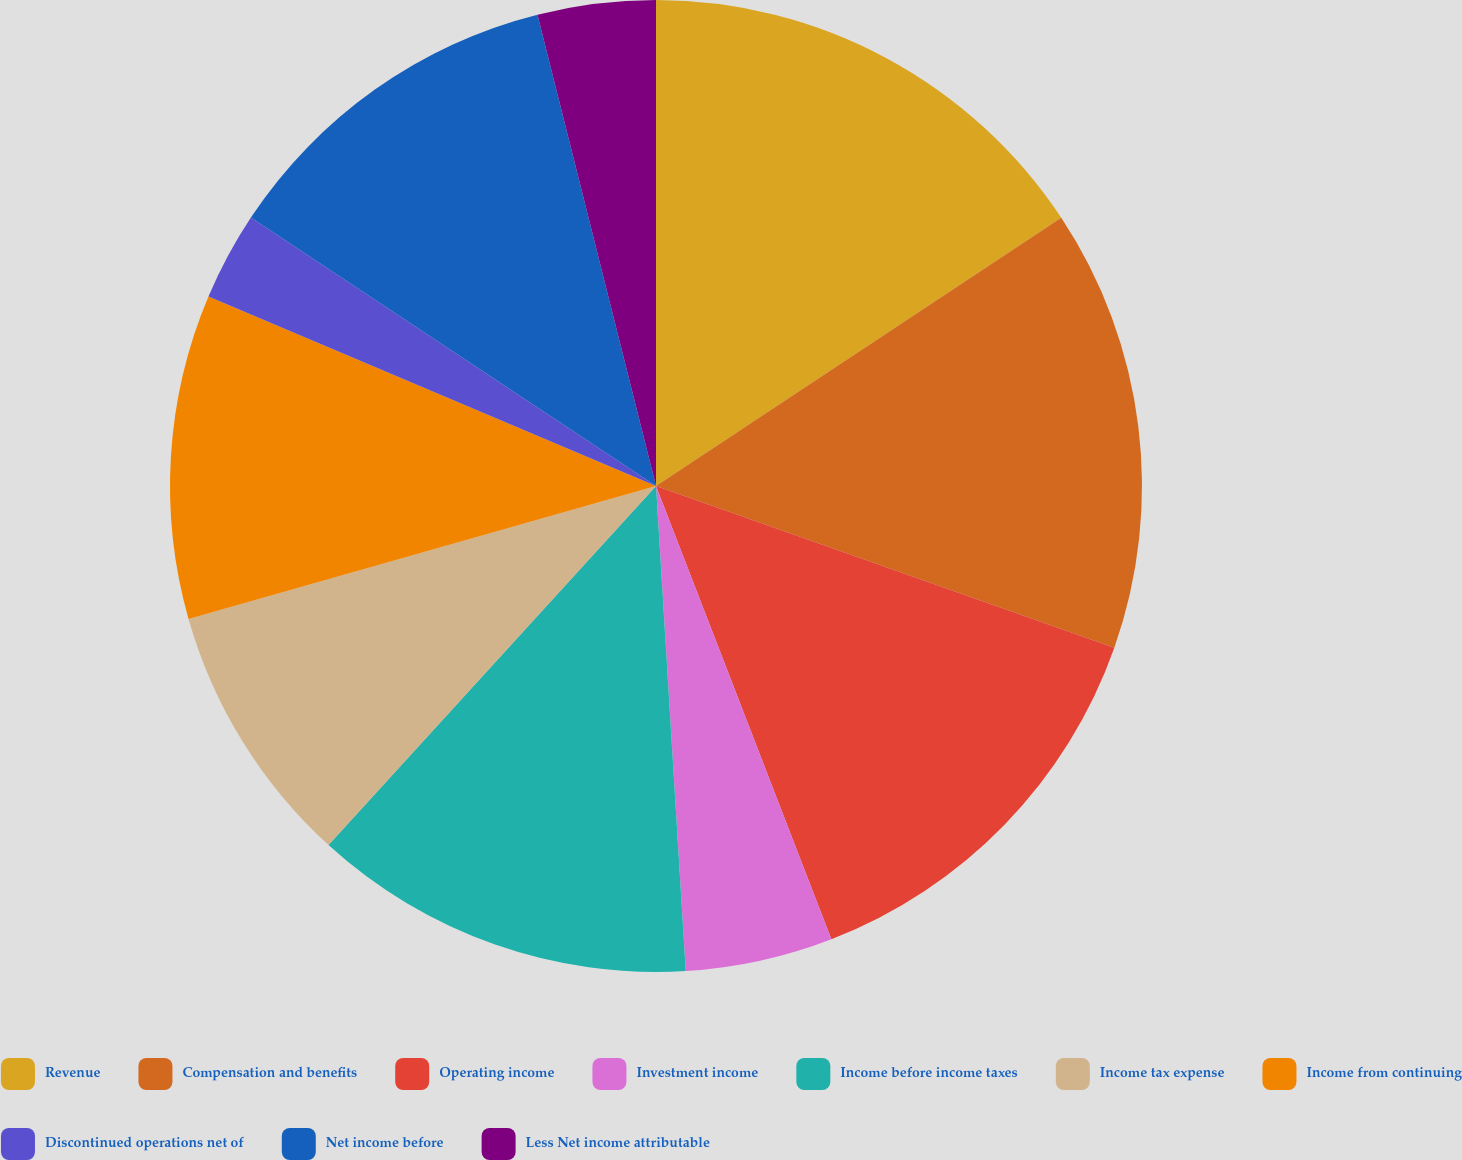Convert chart to OTSL. <chart><loc_0><loc_0><loc_500><loc_500><pie_chart><fcel>Revenue<fcel>Compensation and benefits<fcel>Operating income<fcel>Investment income<fcel>Income before income taxes<fcel>Income tax expense<fcel>Income from continuing<fcel>Discontinued operations net of<fcel>Net income before<fcel>Less Net income attributable<nl><fcel>15.69%<fcel>14.7%<fcel>13.72%<fcel>4.9%<fcel>12.74%<fcel>8.82%<fcel>10.78%<fcel>2.94%<fcel>11.76%<fcel>3.92%<nl></chart> 